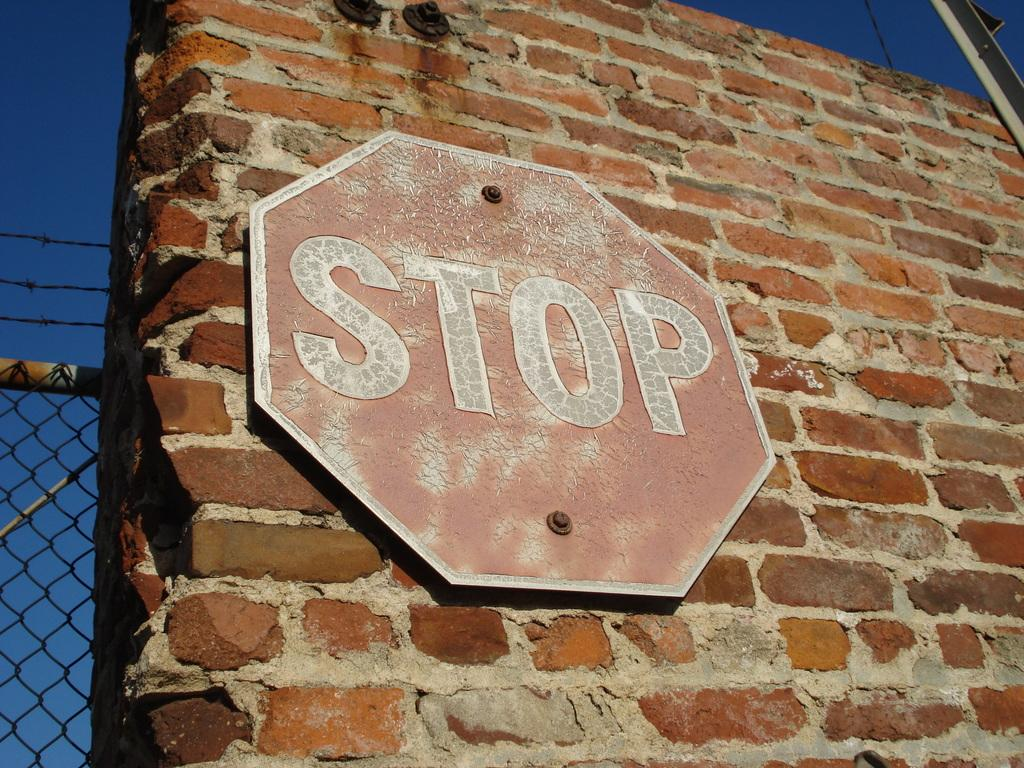<image>
Give a short and clear explanation of the subsequent image. A faded sign on an old brick wall has the word "stop" on it 